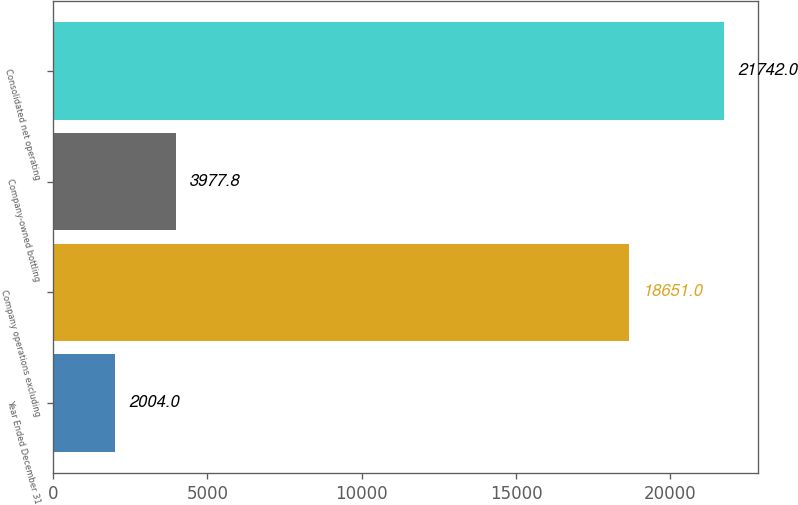<chart> <loc_0><loc_0><loc_500><loc_500><bar_chart><fcel>Year Ended December 31<fcel>Company operations excluding<fcel>Company-owned bottling<fcel>Consolidated net operating<nl><fcel>2004<fcel>18651<fcel>3977.8<fcel>21742<nl></chart> 